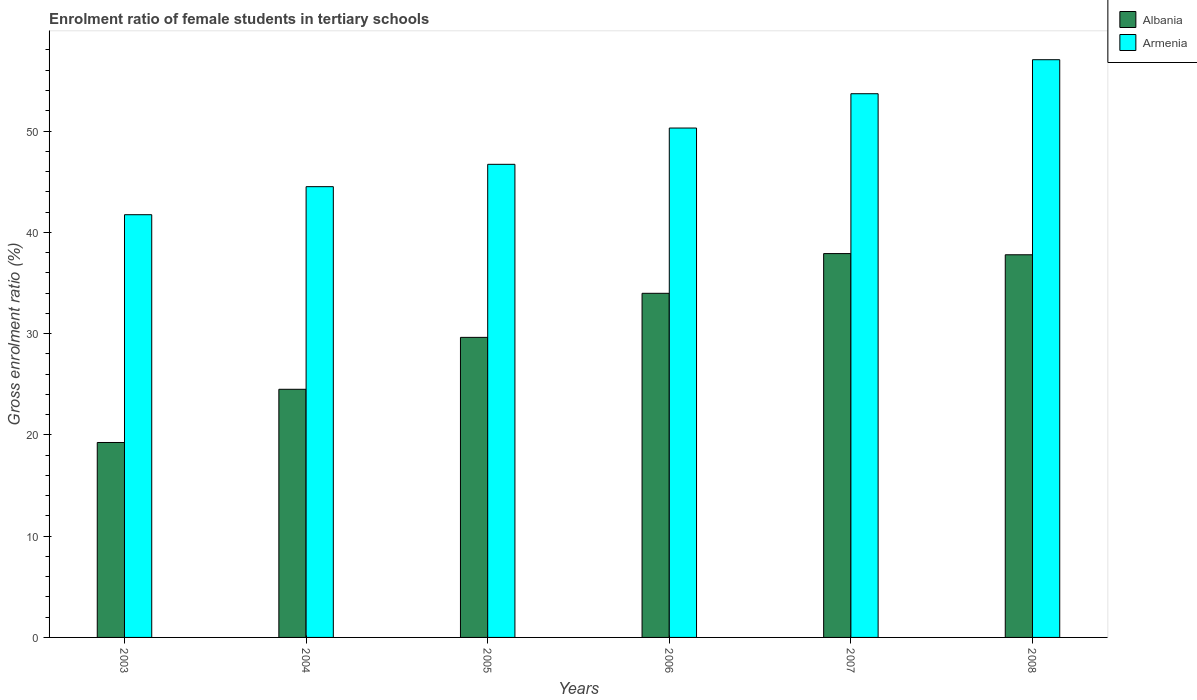How many groups of bars are there?
Provide a succinct answer. 6. What is the label of the 2nd group of bars from the left?
Your answer should be very brief. 2004. In how many cases, is the number of bars for a given year not equal to the number of legend labels?
Offer a very short reply. 0. What is the enrolment ratio of female students in tertiary schools in Armenia in 2006?
Your response must be concise. 50.29. Across all years, what is the maximum enrolment ratio of female students in tertiary schools in Armenia?
Provide a short and direct response. 57.04. Across all years, what is the minimum enrolment ratio of female students in tertiary schools in Albania?
Your response must be concise. 19.25. In which year was the enrolment ratio of female students in tertiary schools in Albania maximum?
Your answer should be very brief. 2007. In which year was the enrolment ratio of female students in tertiary schools in Albania minimum?
Offer a very short reply. 2003. What is the total enrolment ratio of female students in tertiary schools in Armenia in the graph?
Your response must be concise. 293.97. What is the difference between the enrolment ratio of female students in tertiary schools in Armenia in 2003 and that in 2004?
Make the answer very short. -2.77. What is the difference between the enrolment ratio of female students in tertiary schools in Armenia in 2003 and the enrolment ratio of female students in tertiary schools in Albania in 2004?
Offer a terse response. 17.24. What is the average enrolment ratio of female students in tertiary schools in Armenia per year?
Provide a short and direct response. 49. In the year 2007, what is the difference between the enrolment ratio of female students in tertiary schools in Albania and enrolment ratio of female students in tertiary schools in Armenia?
Your response must be concise. -15.78. In how many years, is the enrolment ratio of female students in tertiary schools in Albania greater than 40 %?
Provide a succinct answer. 0. What is the ratio of the enrolment ratio of female students in tertiary schools in Armenia in 2005 to that in 2006?
Keep it short and to the point. 0.93. Is the difference between the enrolment ratio of female students in tertiary schools in Albania in 2003 and 2008 greater than the difference between the enrolment ratio of female students in tertiary schools in Armenia in 2003 and 2008?
Offer a terse response. No. What is the difference between the highest and the second highest enrolment ratio of female students in tertiary schools in Armenia?
Give a very brief answer. 3.36. What is the difference between the highest and the lowest enrolment ratio of female students in tertiary schools in Albania?
Your response must be concise. 18.65. Is the sum of the enrolment ratio of female students in tertiary schools in Albania in 2003 and 2008 greater than the maximum enrolment ratio of female students in tertiary schools in Armenia across all years?
Your answer should be compact. No. What does the 2nd bar from the left in 2003 represents?
Make the answer very short. Armenia. What does the 1st bar from the right in 2006 represents?
Provide a short and direct response. Armenia. Are all the bars in the graph horizontal?
Offer a terse response. No. How many years are there in the graph?
Offer a very short reply. 6. Are the values on the major ticks of Y-axis written in scientific E-notation?
Provide a short and direct response. No. Does the graph contain any zero values?
Keep it short and to the point. No. Does the graph contain grids?
Provide a short and direct response. No. What is the title of the graph?
Offer a very short reply. Enrolment ratio of female students in tertiary schools. Does "Bermuda" appear as one of the legend labels in the graph?
Provide a short and direct response. No. What is the label or title of the X-axis?
Your answer should be compact. Years. What is the Gross enrolment ratio (%) in Albania in 2003?
Provide a short and direct response. 19.25. What is the Gross enrolment ratio (%) in Armenia in 2003?
Offer a very short reply. 41.74. What is the Gross enrolment ratio (%) in Albania in 2004?
Your answer should be compact. 24.5. What is the Gross enrolment ratio (%) in Armenia in 2004?
Keep it short and to the point. 44.51. What is the Gross enrolment ratio (%) in Albania in 2005?
Provide a succinct answer. 29.63. What is the Gross enrolment ratio (%) in Armenia in 2005?
Keep it short and to the point. 46.71. What is the Gross enrolment ratio (%) in Albania in 2006?
Provide a short and direct response. 33.98. What is the Gross enrolment ratio (%) in Armenia in 2006?
Provide a short and direct response. 50.29. What is the Gross enrolment ratio (%) in Albania in 2007?
Give a very brief answer. 37.9. What is the Gross enrolment ratio (%) in Armenia in 2007?
Ensure brevity in your answer.  53.68. What is the Gross enrolment ratio (%) of Albania in 2008?
Provide a succinct answer. 37.78. What is the Gross enrolment ratio (%) of Armenia in 2008?
Ensure brevity in your answer.  57.04. Across all years, what is the maximum Gross enrolment ratio (%) in Albania?
Ensure brevity in your answer.  37.9. Across all years, what is the maximum Gross enrolment ratio (%) in Armenia?
Provide a short and direct response. 57.04. Across all years, what is the minimum Gross enrolment ratio (%) of Albania?
Offer a very short reply. 19.25. Across all years, what is the minimum Gross enrolment ratio (%) of Armenia?
Give a very brief answer. 41.74. What is the total Gross enrolment ratio (%) in Albania in the graph?
Make the answer very short. 183.03. What is the total Gross enrolment ratio (%) of Armenia in the graph?
Offer a terse response. 293.97. What is the difference between the Gross enrolment ratio (%) of Albania in 2003 and that in 2004?
Your response must be concise. -5.25. What is the difference between the Gross enrolment ratio (%) in Armenia in 2003 and that in 2004?
Give a very brief answer. -2.77. What is the difference between the Gross enrolment ratio (%) of Albania in 2003 and that in 2005?
Your answer should be compact. -10.38. What is the difference between the Gross enrolment ratio (%) in Armenia in 2003 and that in 2005?
Ensure brevity in your answer.  -4.98. What is the difference between the Gross enrolment ratio (%) in Albania in 2003 and that in 2006?
Your answer should be very brief. -14.73. What is the difference between the Gross enrolment ratio (%) of Armenia in 2003 and that in 2006?
Provide a short and direct response. -8.56. What is the difference between the Gross enrolment ratio (%) in Albania in 2003 and that in 2007?
Your answer should be compact. -18.65. What is the difference between the Gross enrolment ratio (%) in Armenia in 2003 and that in 2007?
Provide a succinct answer. -11.95. What is the difference between the Gross enrolment ratio (%) of Albania in 2003 and that in 2008?
Offer a terse response. -18.53. What is the difference between the Gross enrolment ratio (%) in Armenia in 2003 and that in 2008?
Offer a terse response. -15.3. What is the difference between the Gross enrolment ratio (%) in Albania in 2004 and that in 2005?
Your answer should be compact. -5.13. What is the difference between the Gross enrolment ratio (%) in Armenia in 2004 and that in 2005?
Give a very brief answer. -2.21. What is the difference between the Gross enrolment ratio (%) of Albania in 2004 and that in 2006?
Provide a short and direct response. -9.48. What is the difference between the Gross enrolment ratio (%) of Armenia in 2004 and that in 2006?
Offer a terse response. -5.79. What is the difference between the Gross enrolment ratio (%) in Albania in 2004 and that in 2007?
Ensure brevity in your answer.  -13.4. What is the difference between the Gross enrolment ratio (%) of Armenia in 2004 and that in 2007?
Keep it short and to the point. -9.18. What is the difference between the Gross enrolment ratio (%) of Albania in 2004 and that in 2008?
Your response must be concise. -13.28. What is the difference between the Gross enrolment ratio (%) of Armenia in 2004 and that in 2008?
Give a very brief answer. -12.54. What is the difference between the Gross enrolment ratio (%) in Albania in 2005 and that in 2006?
Your response must be concise. -4.35. What is the difference between the Gross enrolment ratio (%) of Armenia in 2005 and that in 2006?
Your response must be concise. -3.58. What is the difference between the Gross enrolment ratio (%) of Albania in 2005 and that in 2007?
Ensure brevity in your answer.  -8.27. What is the difference between the Gross enrolment ratio (%) of Armenia in 2005 and that in 2007?
Offer a terse response. -6.97. What is the difference between the Gross enrolment ratio (%) in Albania in 2005 and that in 2008?
Offer a very short reply. -8.15. What is the difference between the Gross enrolment ratio (%) of Armenia in 2005 and that in 2008?
Your answer should be very brief. -10.33. What is the difference between the Gross enrolment ratio (%) of Albania in 2006 and that in 2007?
Your response must be concise. -3.92. What is the difference between the Gross enrolment ratio (%) of Armenia in 2006 and that in 2007?
Make the answer very short. -3.39. What is the difference between the Gross enrolment ratio (%) in Albania in 2006 and that in 2008?
Provide a short and direct response. -3.8. What is the difference between the Gross enrolment ratio (%) of Armenia in 2006 and that in 2008?
Make the answer very short. -6.75. What is the difference between the Gross enrolment ratio (%) of Albania in 2007 and that in 2008?
Ensure brevity in your answer.  0.12. What is the difference between the Gross enrolment ratio (%) in Armenia in 2007 and that in 2008?
Ensure brevity in your answer.  -3.36. What is the difference between the Gross enrolment ratio (%) of Albania in 2003 and the Gross enrolment ratio (%) of Armenia in 2004?
Provide a succinct answer. -25.26. What is the difference between the Gross enrolment ratio (%) of Albania in 2003 and the Gross enrolment ratio (%) of Armenia in 2005?
Provide a short and direct response. -27.47. What is the difference between the Gross enrolment ratio (%) of Albania in 2003 and the Gross enrolment ratio (%) of Armenia in 2006?
Keep it short and to the point. -31.05. What is the difference between the Gross enrolment ratio (%) in Albania in 2003 and the Gross enrolment ratio (%) in Armenia in 2007?
Ensure brevity in your answer.  -34.44. What is the difference between the Gross enrolment ratio (%) in Albania in 2003 and the Gross enrolment ratio (%) in Armenia in 2008?
Offer a terse response. -37.79. What is the difference between the Gross enrolment ratio (%) of Albania in 2004 and the Gross enrolment ratio (%) of Armenia in 2005?
Offer a terse response. -22.21. What is the difference between the Gross enrolment ratio (%) of Albania in 2004 and the Gross enrolment ratio (%) of Armenia in 2006?
Offer a very short reply. -25.79. What is the difference between the Gross enrolment ratio (%) in Albania in 2004 and the Gross enrolment ratio (%) in Armenia in 2007?
Your answer should be very brief. -29.18. What is the difference between the Gross enrolment ratio (%) of Albania in 2004 and the Gross enrolment ratio (%) of Armenia in 2008?
Provide a succinct answer. -32.54. What is the difference between the Gross enrolment ratio (%) of Albania in 2005 and the Gross enrolment ratio (%) of Armenia in 2006?
Your answer should be compact. -20.67. What is the difference between the Gross enrolment ratio (%) in Albania in 2005 and the Gross enrolment ratio (%) in Armenia in 2007?
Offer a very short reply. -24.06. What is the difference between the Gross enrolment ratio (%) in Albania in 2005 and the Gross enrolment ratio (%) in Armenia in 2008?
Provide a short and direct response. -27.41. What is the difference between the Gross enrolment ratio (%) of Albania in 2006 and the Gross enrolment ratio (%) of Armenia in 2007?
Offer a very short reply. -19.71. What is the difference between the Gross enrolment ratio (%) in Albania in 2006 and the Gross enrolment ratio (%) in Armenia in 2008?
Keep it short and to the point. -23.06. What is the difference between the Gross enrolment ratio (%) of Albania in 2007 and the Gross enrolment ratio (%) of Armenia in 2008?
Keep it short and to the point. -19.14. What is the average Gross enrolment ratio (%) of Albania per year?
Give a very brief answer. 30.5. What is the average Gross enrolment ratio (%) in Armenia per year?
Ensure brevity in your answer.  49. In the year 2003, what is the difference between the Gross enrolment ratio (%) in Albania and Gross enrolment ratio (%) in Armenia?
Provide a short and direct response. -22.49. In the year 2004, what is the difference between the Gross enrolment ratio (%) of Albania and Gross enrolment ratio (%) of Armenia?
Offer a terse response. -20.01. In the year 2005, what is the difference between the Gross enrolment ratio (%) of Albania and Gross enrolment ratio (%) of Armenia?
Give a very brief answer. -17.09. In the year 2006, what is the difference between the Gross enrolment ratio (%) in Albania and Gross enrolment ratio (%) in Armenia?
Make the answer very short. -16.32. In the year 2007, what is the difference between the Gross enrolment ratio (%) of Albania and Gross enrolment ratio (%) of Armenia?
Ensure brevity in your answer.  -15.78. In the year 2008, what is the difference between the Gross enrolment ratio (%) in Albania and Gross enrolment ratio (%) in Armenia?
Provide a succinct answer. -19.26. What is the ratio of the Gross enrolment ratio (%) of Albania in 2003 to that in 2004?
Keep it short and to the point. 0.79. What is the ratio of the Gross enrolment ratio (%) in Armenia in 2003 to that in 2004?
Make the answer very short. 0.94. What is the ratio of the Gross enrolment ratio (%) of Albania in 2003 to that in 2005?
Provide a short and direct response. 0.65. What is the ratio of the Gross enrolment ratio (%) of Armenia in 2003 to that in 2005?
Offer a very short reply. 0.89. What is the ratio of the Gross enrolment ratio (%) of Albania in 2003 to that in 2006?
Offer a terse response. 0.57. What is the ratio of the Gross enrolment ratio (%) of Armenia in 2003 to that in 2006?
Provide a succinct answer. 0.83. What is the ratio of the Gross enrolment ratio (%) of Albania in 2003 to that in 2007?
Ensure brevity in your answer.  0.51. What is the ratio of the Gross enrolment ratio (%) in Armenia in 2003 to that in 2007?
Provide a succinct answer. 0.78. What is the ratio of the Gross enrolment ratio (%) in Albania in 2003 to that in 2008?
Your response must be concise. 0.51. What is the ratio of the Gross enrolment ratio (%) in Armenia in 2003 to that in 2008?
Offer a very short reply. 0.73. What is the ratio of the Gross enrolment ratio (%) of Albania in 2004 to that in 2005?
Provide a short and direct response. 0.83. What is the ratio of the Gross enrolment ratio (%) in Armenia in 2004 to that in 2005?
Provide a succinct answer. 0.95. What is the ratio of the Gross enrolment ratio (%) in Albania in 2004 to that in 2006?
Your answer should be very brief. 0.72. What is the ratio of the Gross enrolment ratio (%) of Armenia in 2004 to that in 2006?
Make the answer very short. 0.88. What is the ratio of the Gross enrolment ratio (%) of Albania in 2004 to that in 2007?
Ensure brevity in your answer.  0.65. What is the ratio of the Gross enrolment ratio (%) of Armenia in 2004 to that in 2007?
Make the answer very short. 0.83. What is the ratio of the Gross enrolment ratio (%) of Albania in 2004 to that in 2008?
Ensure brevity in your answer.  0.65. What is the ratio of the Gross enrolment ratio (%) of Armenia in 2004 to that in 2008?
Give a very brief answer. 0.78. What is the ratio of the Gross enrolment ratio (%) of Albania in 2005 to that in 2006?
Ensure brevity in your answer.  0.87. What is the ratio of the Gross enrolment ratio (%) of Armenia in 2005 to that in 2006?
Offer a terse response. 0.93. What is the ratio of the Gross enrolment ratio (%) in Albania in 2005 to that in 2007?
Keep it short and to the point. 0.78. What is the ratio of the Gross enrolment ratio (%) in Armenia in 2005 to that in 2007?
Offer a terse response. 0.87. What is the ratio of the Gross enrolment ratio (%) in Albania in 2005 to that in 2008?
Your answer should be very brief. 0.78. What is the ratio of the Gross enrolment ratio (%) in Armenia in 2005 to that in 2008?
Ensure brevity in your answer.  0.82. What is the ratio of the Gross enrolment ratio (%) of Albania in 2006 to that in 2007?
Your answer should be very brief. 0.9. What is the ratio of the Gross enrolment ratio (%) of Armenia in 2006 to that in 2007?
Offer a terse response. 0.94. What is the ratio of the Gross enrolment ratio (%) of Albania in 2006 to that in 2008?
Make the answer very short. 0.9. What is the ratio of the Gross enrolment ratio (%) of Armenia in 2006 to that in 2008?
Ensure brevity in your answer.  0.88. What is the ratio of the Gross enrolment ratio (%) in Albania in 2007 to that in 2008?
Your answer should be compact. 1. What is the ratio of the Gross enrolment ratio (%) of Armenia in 2007 to that in 2008?
Offer a very short reply. 0.94. What is the difference between the highest and the second highest Gross enrolment ratio (%) of Albania?
Your answer should be compact. 0.12. What is the difference between the highest and the second highest Gross enrolment ratio (%) of Armenia?
Provide a short and direct response. 3.36. What is the difference between the highest and the lowest Gross enrolment ratio (%) of Albania?
Offer a very short reply. 18.65. What is the difference between the highest and the lowest Gross enrolment ratio (%) of Armenia?
Ensure brevity in your answer.  15.3. 